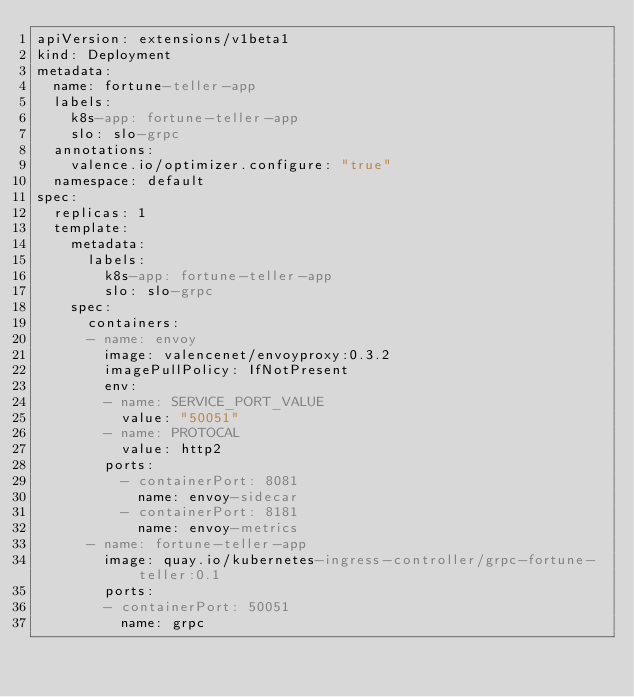Convert code to text. <code><loc_0><loc_0><loc_500><loc_500><_YAML_>apiVersion: extensions/v1beta1
kind: Deployment
metadata:
  name: fortune-teller-app
  labels:
    k8s-app: fortune-teller-app
    slo: slo-grpc
  annotations:
    valence.io/optimizer.configure: "true"
  namespace: default
spec:
  replicas: 1
  template:
    metadata:
      labels:
        k8s-app: fortune-teller-app
        slo: slo-grpc
    spec:
      containers:
      - name: envoy
        image: valencenet/envoyproxy:0.3.2
        imagePullPolicy: IfNotPresent
        env:
        - name: SERVICE_PORT_VALUE
          value: "50051"
        - name: PROTOCAL
          value: http2
        ports:
          - containerPort: 8081
            name: envoy-sidecar
          - containerPort: 8181
            name: envoy-metrics
      - name: fortune-teller-app
        image: quay.io/kubernetes-ingress-controller/grpc-fortune-teller:0.1
        ports:
        - containerPort: 50051
          name: grpc</code> 